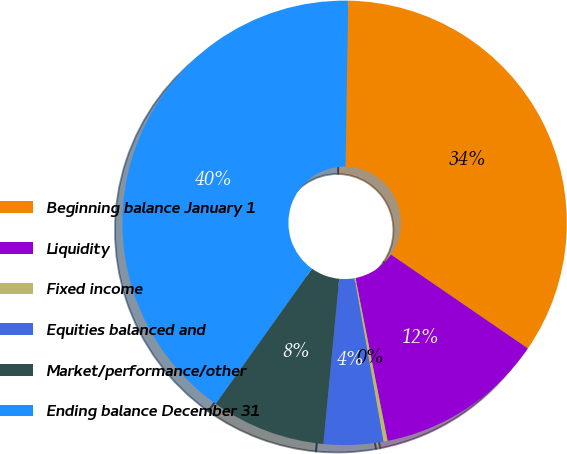<chart> <loc_0><loc_0><loc_500><loc_500><pie_chart><fcel>Beginning balance January 1<fcel>Liquidity<fcel>Fixed income<fcel>Equities balanced and<fcel>Market/performance/other<fcel>Ending balance December 31<nl><fcel>34.31%<fcel>12.34%<fcel>0.3%<fcel>4.32%<fcel>8.33%<fcel>40.41%<nl></chart> 